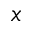<formula> <loc_0><loc_0><loc_500><loc_500>_ { x }</formula> 